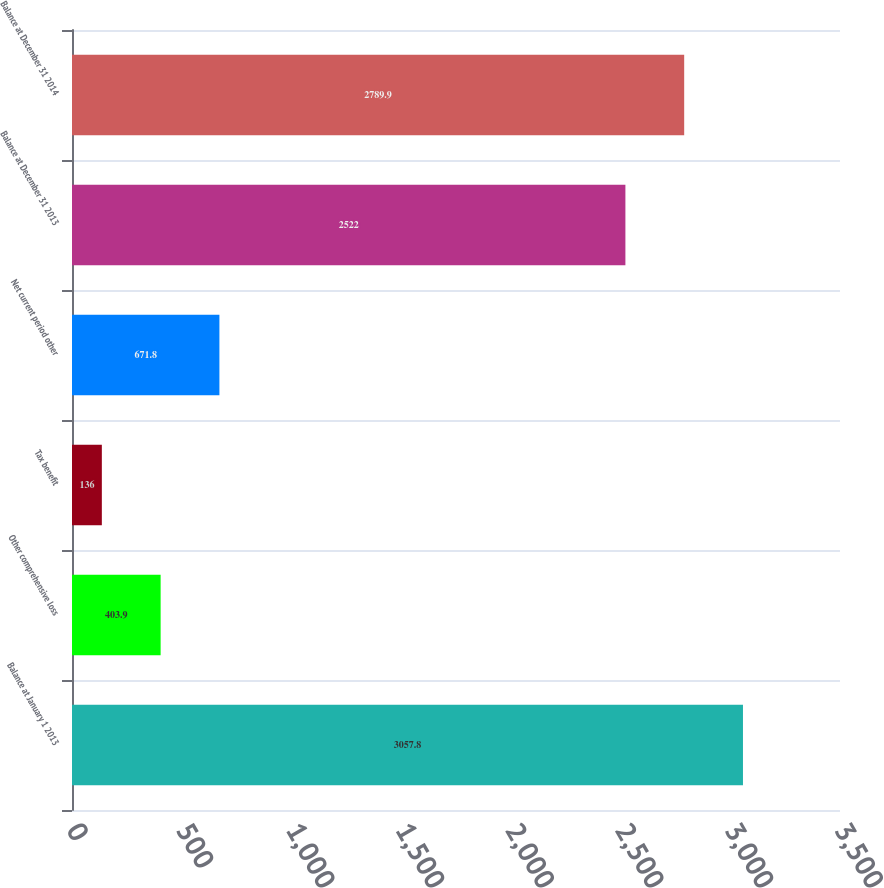Convert chart. <chart><loc_0><loc_0><loc_500><loc_500><bar_chart><fcel>Balance at January 1 2013<fcel>Other comprehensive loss<fcel>Tax benefit<fcel>Net current period other<fcel>Balance at December 31 2013<fcel>Balance at December 31 2014<nl><fcel>3057.8<fcel>403.9<fcel>136<fcel>671.8<fcel>2522<fcel>2789.9<nl></chart> 